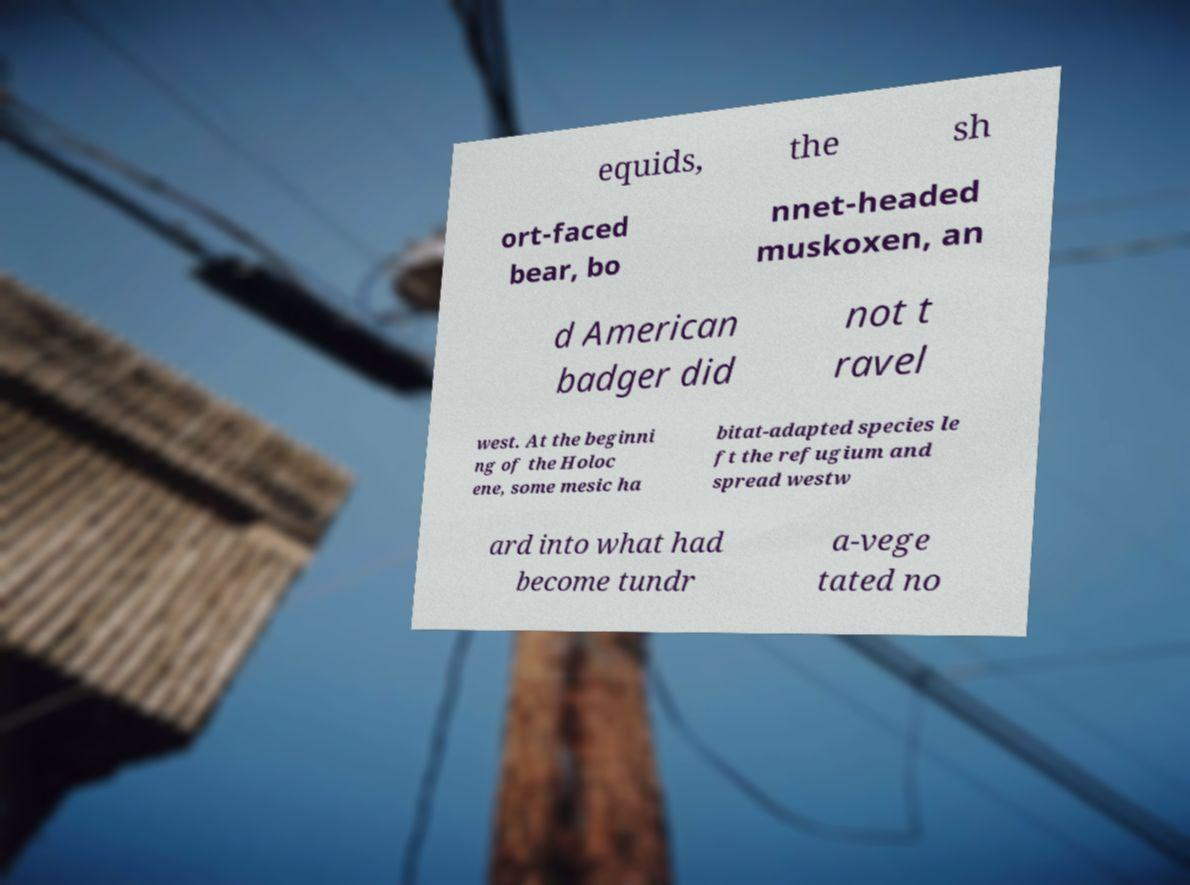I need the written content from this picture converted into text. Can you do that? equids, the sh ort-faced bear, bo nnet-headed muskoxen, an d American badger did not t ravel west. At the beginni ng of the Holoc ene, some mesic ha bitat-adapted species le ft the refugium and spread westw ard into what had become tundr a-vege tated no 